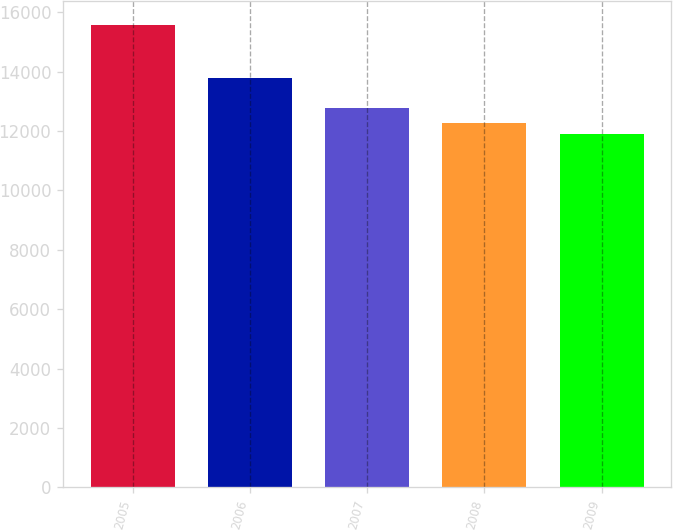<chart> <loc_0><loc_0><loc_500><loc_500><bar_chart><fcel>2005<fcel>2006<fcel>2007<fcel>2008<fcel>2009<nl><fcel>15592<fcel>13777<fcel>12780<fcel>12287.2<fcel>11920<nl></chart> 